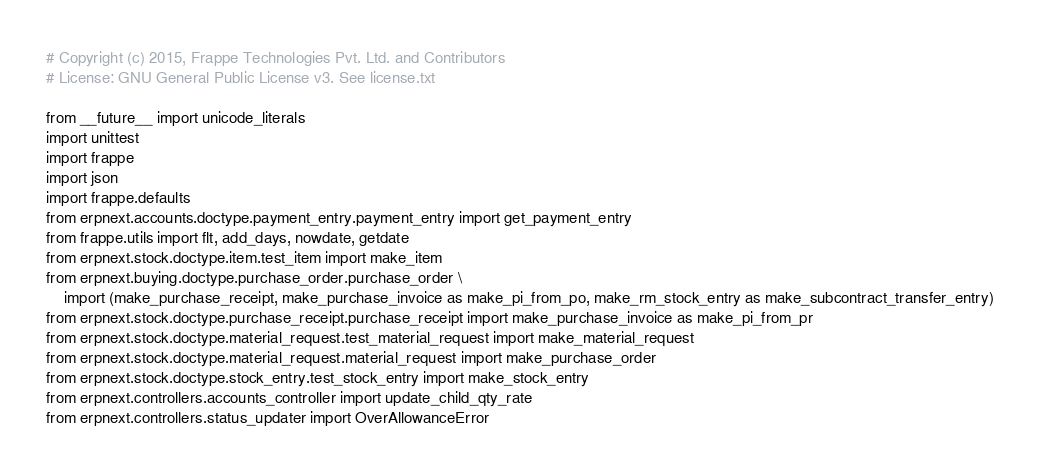<code> <loc_0><loc_0><loc_500><loc_500><_Python_># Copyright (c) 2015, Frappe Technologies Pvt. Ltd. and Contributors
# License: GNU General Public License v3. See license.txt

from __future__ import unicode_literals
import unittest
import frappe
import json
import frappe.defaults
from erpnext.accounts.doctype.payment_entry.payment_entry import get_payment_entry
from frappe.utils import flt, add_days, nowdate, getdate
from erpnext.stock.doctype.item.test_item import make_item
from erpnext.buying.doctype.purchase_order.purchase_order \
	import (make_purchase_receipt, make_purchase_invoice as make_pi_from_po, make_rm_stock_entry as make_subcontract_transfer_entry)
from erpnext.stock.doctype.purchase_receipt.purchase_receipt import make_purchase_invoice as make_pi_from_pr
from erpnext.stock.doctype.material_request.test_material_request import make_material_request
from erpnext.stock.doctype.material_request.material_request import make_purchase_order
from erpnext.stock.doctype.stock_entry.test_stock_entry import make_stock_entry
from erpnext.controllers.accounts_controller import update_child_qty_rate
from erpnext.controllers.status_updater import OverAllowanceError</code> 